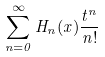Convert formula to latex. <formula><loc_0><loc_0><loc_500><loc_500>\sum _ { n = 0 } ^ { \infty } H _ { n } ( x ) \frac { t ^ { n } } { n ! }</formula> 